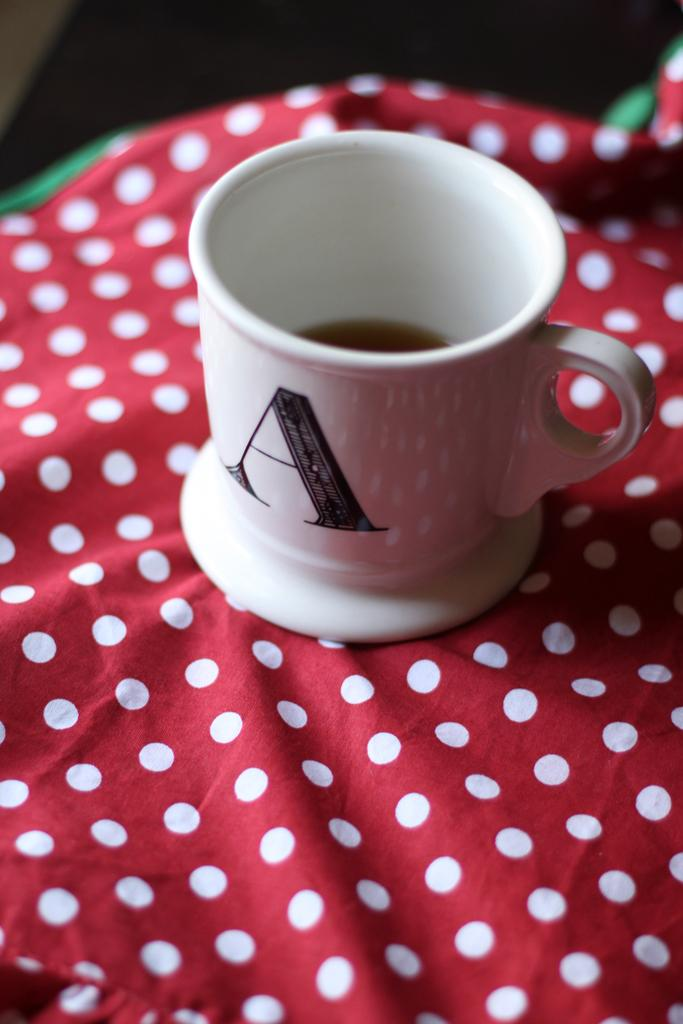<image>
Give a short and clear explanation of the subsequent image. A white cup with the letter A, sits on a red spotted table cloth. 